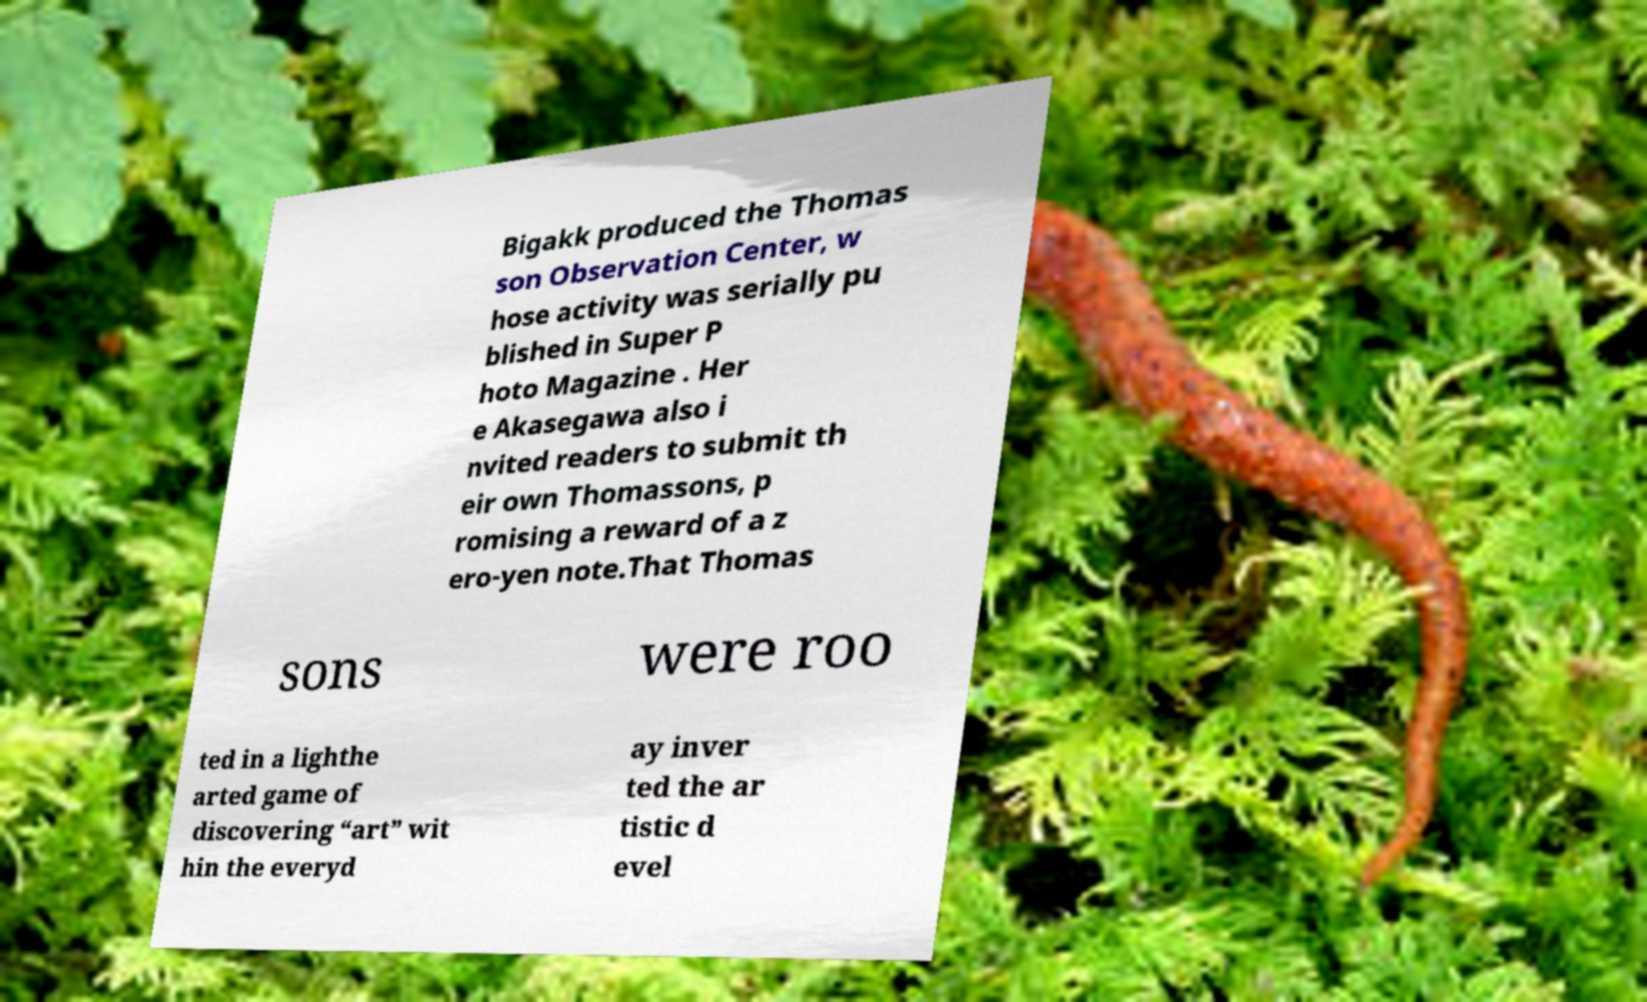There's text embedded in this image that I need extracted. Can you transcribe it verbatim? Bigakk produced the Thomas son Observation Center, w hose activity was serially pu blished in Super P hoto Magazine . Her e Akasegawa also i nvited readers to submit th eir own Thomassons, p romising a reward of a z ero-yen note.That Thomas sons were roo ted in a lighthe arted game of discovering “art” wit hin the everyd ay inver ted the ar tistic d evel 